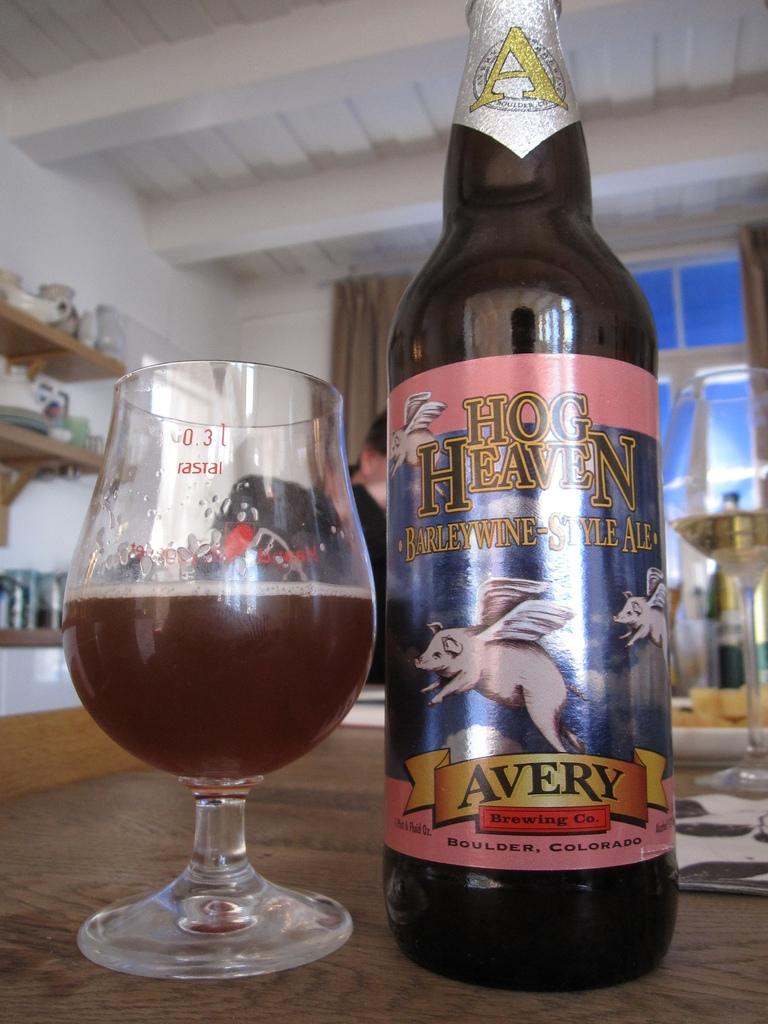<image>
Give a short and clear explanation of the subsequent image. A glass and a bottle of Hog Heaven beer placed side by side. 